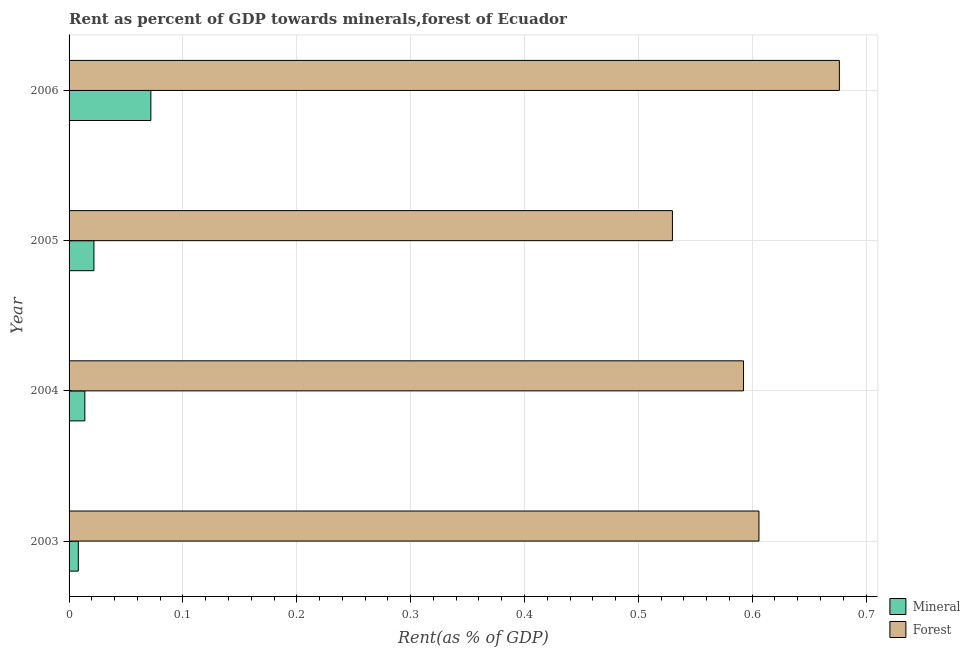How many groups of bars are there?
Your answer should be very brief. 4. Are the number of bars per tick equal to the number of legend labels?
Provide a succinct answer. Yes. Are the number of bars on each tick of the Y-axis equal?
Offer a terse response. Yes. How many bars are there on the 2nd tick from the top?
Your answer should be compact. 2. What is the label of the 2nd group of bars from the top?
Your response must be concise. 2005. In how many cases, is the number of bars for a given year not equal to the number of legend labels?
Provide a short and direct response. 0. What is the mineral rent in 2006?
Provide a succinct answer. 0.07. Across all years, what is the maximum mineral rent?
Your answer should be very brief. 0.07. Across all years, what is the minimum forest rent?
Ensure brevity in your answer.  0.53. What is the total mineral rent in the graph?
Keep it short and to the point. 0.12. What is the difference between the mineral rent in 2004 and that in 2005?
Your response must be concise. -0.01. What is the difference between the forest rent in 2005 and the mineral rent in 2003?
Make the answer very short. 0.52. What is the average mineral rent per year?
Your response must be concise. 0.03. In the year 2005, what is the difference between the forest rent and mineral rent?
Keep it short and to the point. 0.51. In how many years, is the mineral rent greater than 0.6000000000000001 %?
Make the answer very short. 0. What is the ratio of the mineral rent in 2004 to that in 2006?
Offer a very short reply. 0.19. Is the difference between the forest rent in 2005 and 2006 greater than the difference between the mineral rent in 2005 and 2006?
Offer a very short reply. No. What is the difference between the highest and the second highest forest rent?
Make the answer very short. 0.07. What is the difference between the highest and the lowest mineral rent?
Give a very brief answer. 0.06. In how many years, is the mineral rent greater than the average mineral rent taken over all years?
Offer a terse response. 1. What does the 1st bar from the top in 2005 represents?
Ensure brevity in your answer.  Forest. What does the 1st bar from the bottom in 2006 represents?
Give a very brief answer. Mineral. Are all the bars in the graph horizontal?
Keep it short and to the point. Yes. How many years are there in the graph?
Provide a short and direct response. 4. Does the graph contain any zero values?
Offer a terse response. No. Does the graph contain grids?
Offer a terse response. Yes. Where does the legend appear in the graph?
Keep it short and to the point. Bottom right. How are the legend labels stacked?
Your answer should be compact. Vertical. What is the title of the graph?
Offer a very short reply. Rent as percent of GDP towards minerals,forest of Ecuador. Does "Public funds" appear as one of the legend labels in the graph?
Provide a short and direct response. No. What is the label or title of the X-axis?
Your response must be concise. Rent(as % of GDP). What is the Rent(as % of GDP) of Mineral in 2003?
Ensure brevity in your answer.  0.01. What is the Rent(as % of GDP) in Forest in 2003?
Give a very brief answer. 0.61. What is the Rent(as % of GDP) of Mineral in 2004?
Give a very brief answer. 0.01. What is the Rent(as % of GDP) in Forest in 2004?
Your answer should be very brief. 0.59. What is the Rent(as % of GDP) in Mineral in 2005?
Give a very brief answer. 0.02. What is the Rent(as % of GDP) in Forest in 2005?
Provide a short and direct response. 0.53. What is the Rent(as % of GDP) of Mineral in 2006?
Provide a succinct answer. 0.07. What is the Rent(as % of GDP) in Forest in 2006?
Provide a short and direct response. 0.68. Across all years, what is the maximum Rent(as % of GDP) of Mineral?
Offer a very short reply. 0.07. Across all years, what is the maximum Rent(as % of GDP) in Forest?
Your response must be concise. 0.68. Across all years, what is the minimum Rent(as % of GDP) of Mineral?
Your response must be concise. 0.01. Across all years, what is the minimum Rent(as % of GDP) of Forest?
Ensure brevity in your answer.  0.53. What is the total Rent(as % of GDP) of Mineral in the graph?
Provide a short and direct response. 0.12. What is the total Rent(as % of GDP) of Forest in the graph?
Provide a succinct answer. 2.4. What is the difference between the Rent(as % of GDP) in Mineral in 2003 and that in 2004?
Offer a very short reply. -0.01. What is the difference between the Rent(as % of GDP) of Forest in 2003 and that in 2004?
Keep it short and to the point. 0.01. What is the difference between the Rent(as % of GDP) in Mineral in 2003 and that in 2005?
Keep it short and to the point. -0.01. What is the difference between the Rent(as % of GDP) in Forest in 2003 and that in 2005?
Ensure brevity in your answer.  0.08. What is the difference between the Rent(as % of GDP) of Mineral in 2003 and that in 2006?
Your answer should be very brief. -0.06. What is the difference between the Rent(as % of GDP) in Forest in 2003 and that in 2006?
Offer a terse response. -0.07. What is the difference between the Rent(as % of GDP) of Mineral in 2004 and that in 2005?
Offer a very short reply. -0.01. What is the difference between the Rent(as % of GDP) of Forest in 2004 and that in 2005?
Your response must be concise. 0.06. What is the difference between the Rent(as % of GDP) in Mineral in 2004 and that in 2006?
Give a very brief answer. -0.06. What is the difference between the Rent(as % of GDP) in Forest in 2004 and that in 2006?
Your answer should be compact. -0.08. What is the difference between the Rent(as % of GDP) in Forest in 2005 and that in 2006?
Offer a very short reply. -0.15. What is the difference between the Rent(as % of GDP) in Mineral in 2003 and the Rent(as % of GDP) in Forest in 2004?
Make the answer very short. -0.58. What is the difference between the Rent(as % of GDP) of Mineral in 2003 and the Rent(as % of GDP) of Forest in 2005?
Provide a short and direct response. -0.52. What is the difference between the Rent(as % of GDP) of Mineral in 2003 and the Rent(as % of GDP) of Forest in 2006?
Your response must be concise. -0.67. What is the difference between the Rent(as % of GDP) of Mineral in 2004 and the Rent(as % of GDP) of Forest in 2005?
Offer a very short reply. -0.52. What is the difference between the Rent(as % of GDP) of Mineral in 2004 and the Rent(as % of GDP) of Forest in 2006?
Provide a short and direct response. -0.66. What is the difference between the Rent(as % of GDP) of Mineral in 2005 and the Rent(as % of GDP) of Forest in 2006?
Offer a very short reply. -0.65. What is the average Rent(as % of GDP) in Mineral per year?
Offer a terse response. 0.03. What is the average Rent(as % of GDP) in Forest per year?
Offer a terse response. 0.6. In the year 2003, what is the difference between the Rent(as % of GDP) of Mineral and Rent(as % of GDP) of Forest?
Your answer should be compact. -0.6. In the year 2004, what is the difference between the Rent(as % of GDP) of Mineral and Rent(as % of GDP) of Forest?
Offer a terse response. -0.58. In the year 2005, what is the difference between the Rent(as % of GDP) of Mineral and Rent(as % of GDP) of Forest?
Keep it short and to the point. -0.51. In the year 2006, what is the difference between the Rent(as % of GDP) of Mineral and Rent(as % of GDP) of Forest?
Ensure brevity in your answer.  -0.6. What is the ratio of the Rent(as % of GDP) in Mineral in 2003 to that in 2004?
Offer a very short reply. 0.59. What is the ratio of the Rent(as % of GDP) of Forest in 2003 to that in 2004?
Provide a succinct answer. 1.02. What is the ratio of the Rent(as % of GDP) in Mineral in 2003 to that in 2005?
Provide a succinct answer. 0.37. What is the ratio of the Rent(as % of GDP) in Forest in 2003 to that in 2005?
Give a very brief answer. 1.14. What is the ratio of the Rent(as % of GDP) in Mineral in 2003 to that in 2006?
Ensure brevity in your answer.  0.11. What is the ratio of the Rent(as % of GDP) in Forest in 2003 to that in 2006?
Your answer should be compact. 0.9. What is the ratio of the Rent(as % of GDP) in Mineral in 2004 to that in 2005?
Provide a short and direct response. 0.63. What is the ratio of the Rent(as % of GDP) in Forest in 2004 to that in 2005?
Offer a very short reply. 1.12. What is the ratio of the Rent(as % of GDP) of Mineral in 2004 to that in 2006?
Ensure brevity in your answer.  0.19. What is the ratio of the Rent(as % of GDP) in Forest in 2004 to that in 2006?
Provide a short and direct response. 0.88. What is the ratio of the Rent(as % of GDP) in Mineral in 2005 to that in 2006?
Your response must be concise. 0.3. What is the ratio of the Rent(as % of GDP) in Forest in 2005 to that in 2006?
Ensure brevity in your answer.  0.78. What is the difference between the highest and the second highest Rent(as % of GDP) in Forest?
Provide a short and direct response. 0.07. What is the difference between the highest and the lowest Rent(as % of GDP) in Mineral?
Make the answer very short. 0.06. What is the difference between the highest and the lowest Rent(as % of GDP) of Forest?
Your answer should be compact. 0.15. 